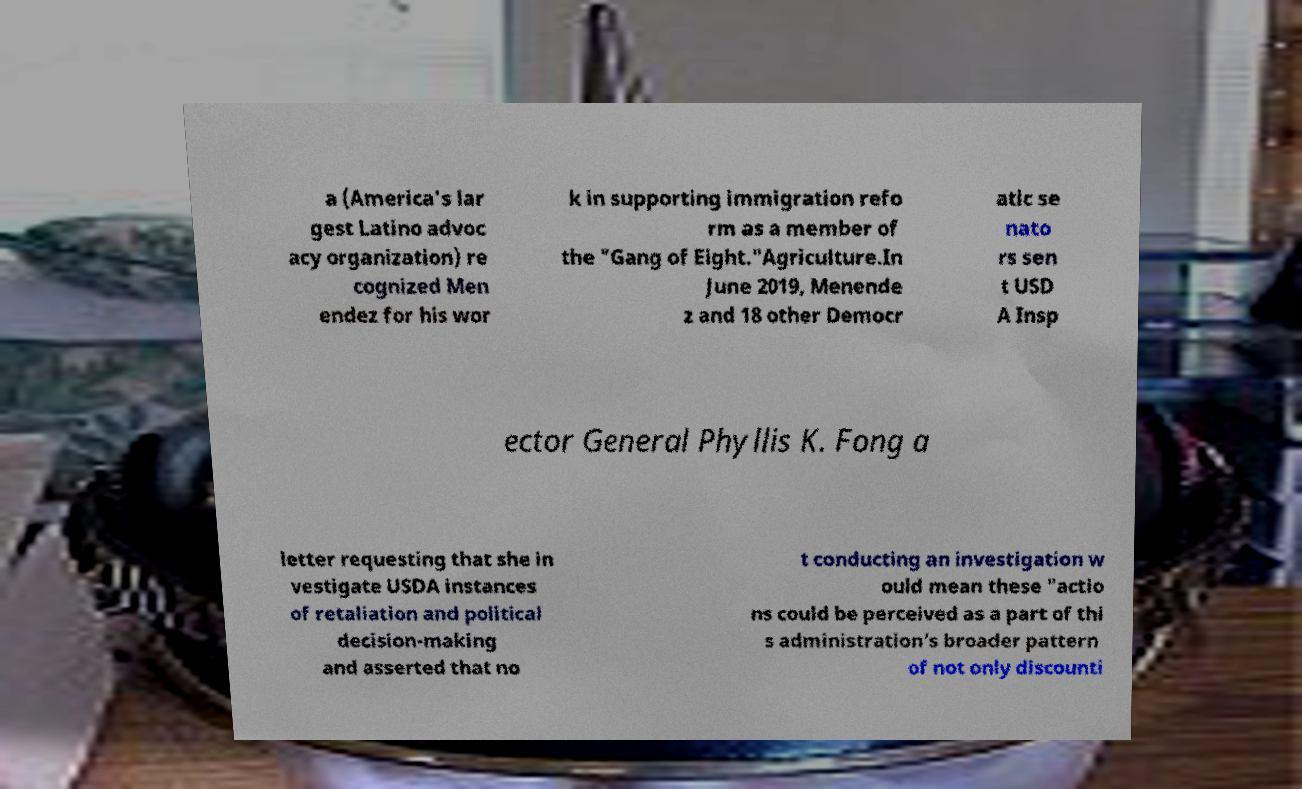There's text embedded in this image that I need extracted. Can you transcribe it verbatim? a (America's lar gest Latino advoc acy organization) re cognized Men endez for his wor k in supporting immigration refo rm as a member of the "Gang of Eight."Agriculture.In June 2019, Menende z and 18 other Democr atic se nato rs sen t USD A Insp ector General Phyllis K. Fong a letter requesting that she in vestigate USDA instances of retaliation and political decision-making and asserted that no t conducting an investigation w ould mean these "actio ns could be perceived as a part of thi s administration’s broader pattern of not only discounti 